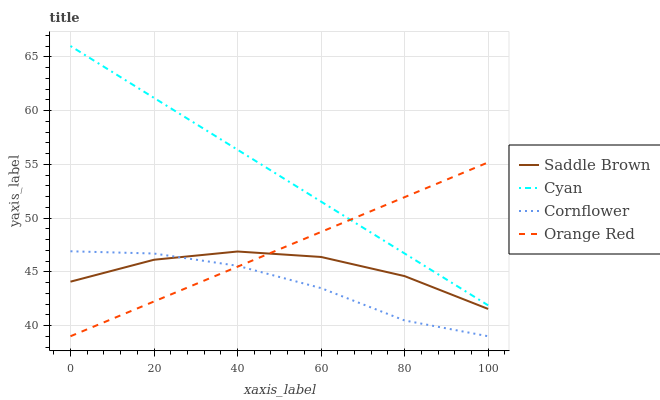Does Saddle Brown have the minimum area under the curve?
Answer yes or no. No. Does Saddle Brown have the maximum area under the curve?
Answer yes or no. No. Is Saddle Brown the smoothest?
Answer yes or no. No. Is Orange Red the roughest?
Answer yes or no. No. Does Saddle Brown have the lowest value?
Answer yes or no. No. Does Orange Red have the highest value?
Answer yes or no. No. Is Saddle Brown less than Cyan?
Answer yes or no. Yes. Is Cyan greater than Cornflower?
Answer yes or no. Yes. Does Saddle Brown intersect Cyan?
Answer yes or no. No. 